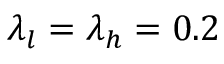Convert formula to latex. <formula><loc_0><loc_0><loc_500><loc_500>\lambda _ { l } = \lambda _ { h } = 0 . 2</formula> 